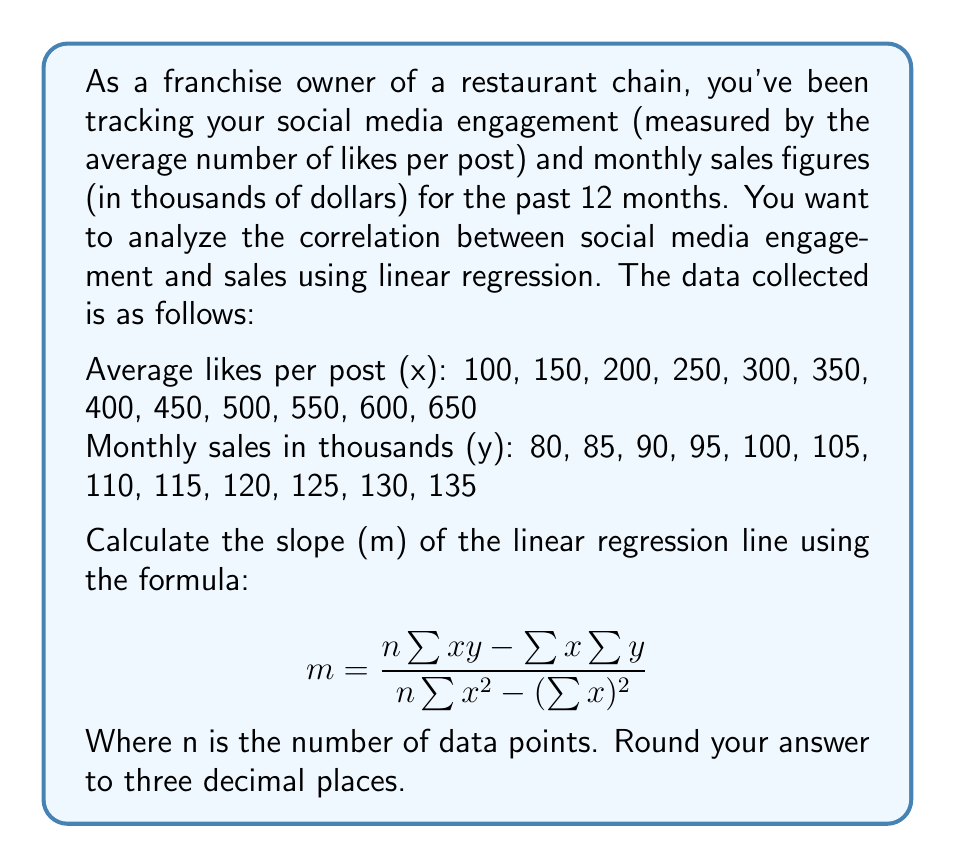Solve this math problem. To solve this problem, we need to follow these steps:

1. Calculate the necessary sums: $\sum{x}$, $\sum{y}$, $\sum{xy}$, and $\sum{x^2}$
2. Apply the formula for the slope (m)
3. Round the result to three decimal places

Step 1: Calculate the sums

$n = 12$ (number of data points)

$\sum{x} = 100 + 150 + 200 + 250 + 300 + 350 + 400 + 450 + 500 + 550 + 600 + 650 = 4500$

$\sum{y} = 80 + 85 + 90 + 95 + 100 + 105 + 110 + 115 + 120 + 125 + 130 + 135 = 1290$

$\sum{xy} = (100 \times 80) + (150 \times 85) + ... + (650 \times 135) = 514,500$

$\sum{x^2} = 100^2 + 150^2 + 200^2 + ... + 650^2 = 2,287,500$

Step 2: Apply the formula

$$ m = \frac{n\sum{xy} - \sum{x}\sum{y}}{n\sum{x^2} - (\sum{x})^2} $$

$$ m = \frac{12(514,500) - (4500)(1290)}{12(2,287,500) - (4500)^2} $$

$$ m = \frac{6,174,000 - 5,805,000}{27,450,000 - 20,250,000} $$

$$ m = \frac{369,000}{7,200,000} $$

$$ m = 0.05125 $$

Step 3: Round to three decimal places

$m = 0.051$
Answer: The slope (m) of the linear regression line is 0.051. 